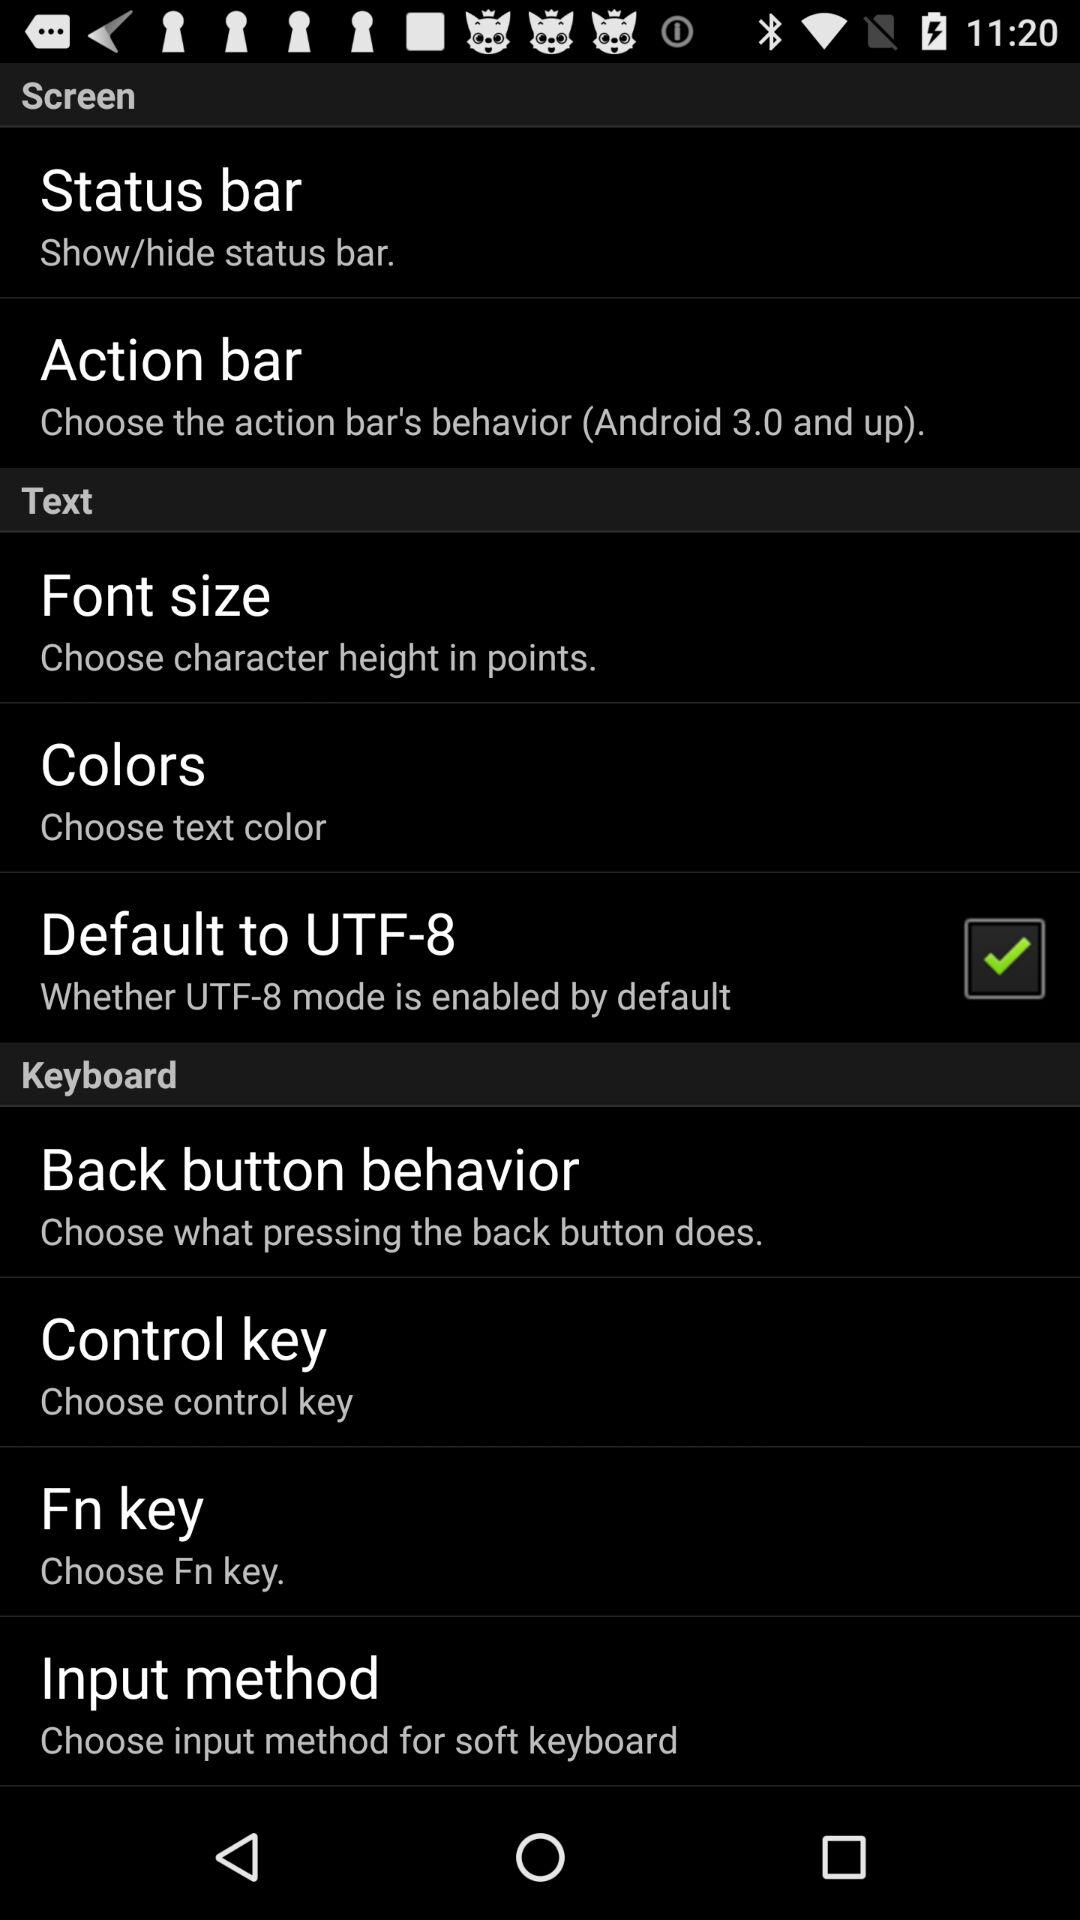What is the status of "Default to UTF-8"? The status is "on". 